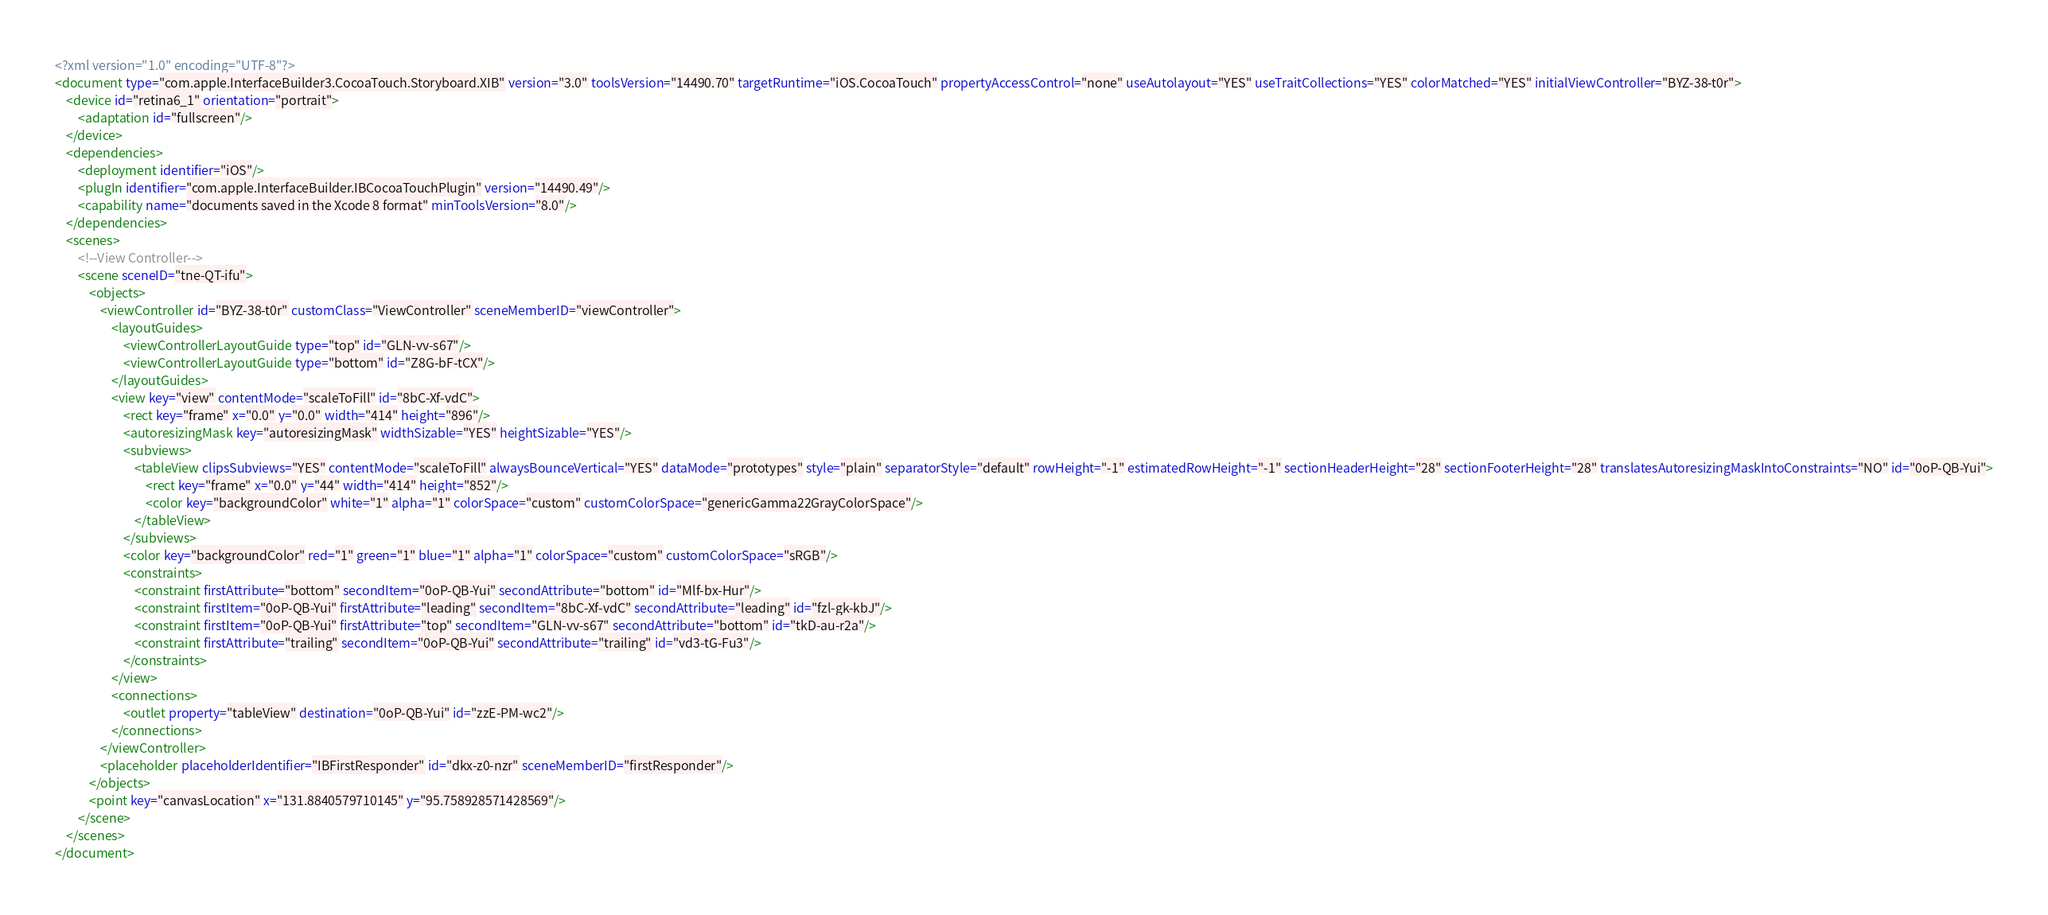<code> <loc_0><loc_0><loc_500><loc_500><_XML_><?xml version="1.0" encoding="UTF-8"?>
<document type="com.apple.InterfaceBuilder3.CocoaTouch.Storyboard.XIB" version="3.0" toolsVersion="14490.70" targetRuntime="iOS.CocoaTouch" propertyAccessControl="none" useAutolayout="YES" useTraitCollections="YES" colorMatched="YES" initialViewController="BYZ-38-t0r">
    <device id="retina6_1" orientation="portrait">
        <adaptation id="fullscreen"/>
    </device>
    <dependencies>
        <deployment identifier="iOS"/>
        <plugIn identifier="com.apple.InterfaceBuilder.IBCocoaTouchPlugin" version="14490.49"/>
        <capability name="documents saved in the Xcode 8 format" minToolsVersion="8.0"/>
    </dependencies>
    <scenes>
        <!--View Controller-->
        <scene sceneID="tne-QT-ifu">
            <objects>
                <viewController id="BYZ-38-t0r" customClass="ViewController" sceneMemberID="viewController">
                    <layoutGuides>
                        <viewControllerLayoutGuide type="top" id="GLN-vv-s67"/>
                        <viewControllerLayoutGuide type="bottom" id="Z8G-bF-tCX"/>
                    </layoutGuides>
                    <view key="view" contentMode="scaleToFill" id="8bC-Xf-vdC">
                        <rect key="frame" x="0.0" y="0.0" width="414" height="896"/>
                        <autoresizingMask key="autoresizingMask" widthSizable="YES" heightSizable="YES"/>
                        <subviews>
                            <tableView clipsSubviews="YES" contentMode="scaleToFill" alwaysBounceVertical="YES" dataMode="prototypes" style="plain" separatorStyle="default" rowHeight="-1" estimatedRowHeight="-1" sectionHeaderHeight="28" sectionFooterHeight="28" translatesAutoresizingMaskIntoConstraints="NO" id="0oP-QB-Yui">
                                <rect key="frame" x="0.0" y="44" width="414" height="852"/>
                                <color key="backgroundColor" white="1" alpha="1" colorSpace="custom" customColorSpace="genericGamma22GrayColorSpace"/>
                            </tableView>
                        </subviews>
                        <color key="backgroundColor" red="1" green="1" blue="1" alpha="1" colorSpace="custom" customColorSpace="sRGB"/>
                        <constraints>
                            <constraint firstAttribute="bottom" secondItem="0oP-QB-Yui" secondAttribute="bottom" id="Mlf-bx-Hur"/>
                            <constraint firstItem="0oP-QB-Yui" firstAttribute="leading" secondItem="8bC-Xf-vdC" secondAttribute="leading" id="fzl-gk-kbJ"/>
                            <constraint firstItem="0oP-QB-Yui" firstAttribute="top" secondItem="GLN-vv-s67" secondAttribute="bottom" id="tkD-au-r2a"/>
                            <constraint firstAttribute="trailing" secondItem="0oP-QB-Yui" secondAttribute="trailing" id="vd3-tG-Fu3"/>
                        </constraints>
                    </view>
                    <connections>
                        <outlet property="tableView" destination="0oP-QB-Yui" id="zzE-PM-wc2"/>
                    </connections>
                </viewController>
                <placeholder placeholderIdentifier="IBFirstResponder" id="dkx-z0-nzr" sceneMemberID="firstResponder"/>
            </objects>
            <point key="canvasLocation" x="131.8840579710145" y="95.758928571428569"/>
        </scene>
    </scenes>
</document>
</code> 